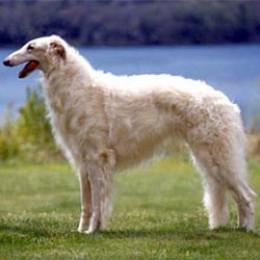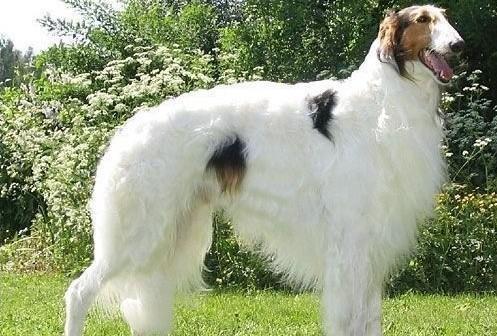The first image is the image on the left, the second image is the image on the right. For the images displayed, is the sentence "Every dog has its mouth open." factually correct? Answer yes or no. Yes. The first image is the image on the left, the second image is the image on the right. Assess this claim about the two images: "There are at most 2 dogs.". Correct or not? Answer yes or no. Yes. 